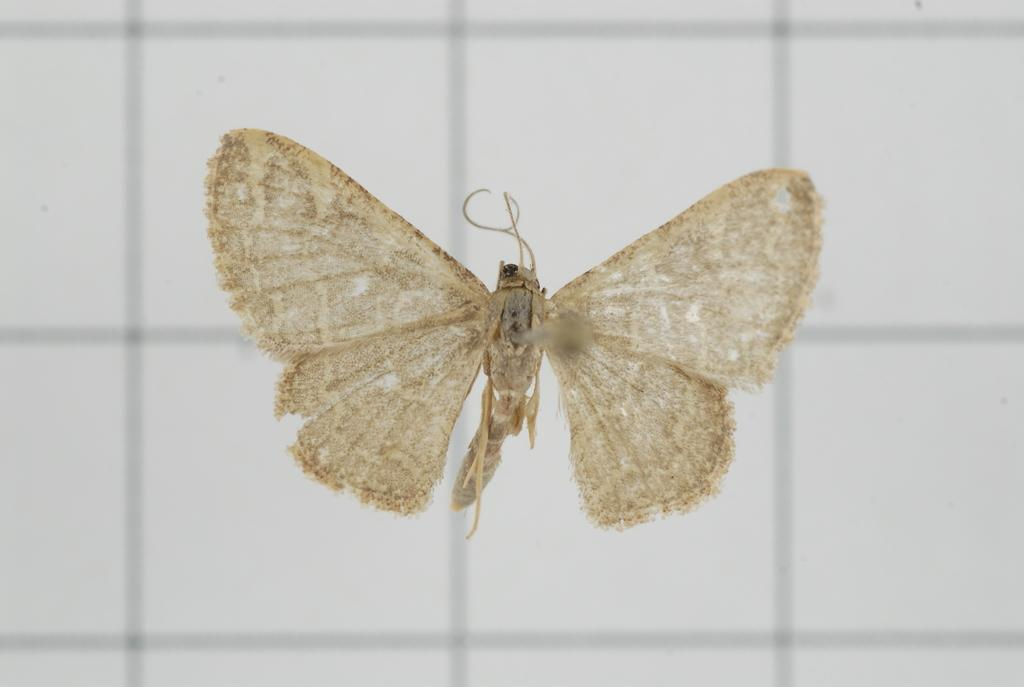What type of animal can be seen in the image? There is a butterfly in the image. What is the background of the image like? The background of the image is white with light black checks. What type of brush is the butterfly using to paint in the image? There is no brush or painting activity present in the image; it features a butterfly against a white and light black checked background. 